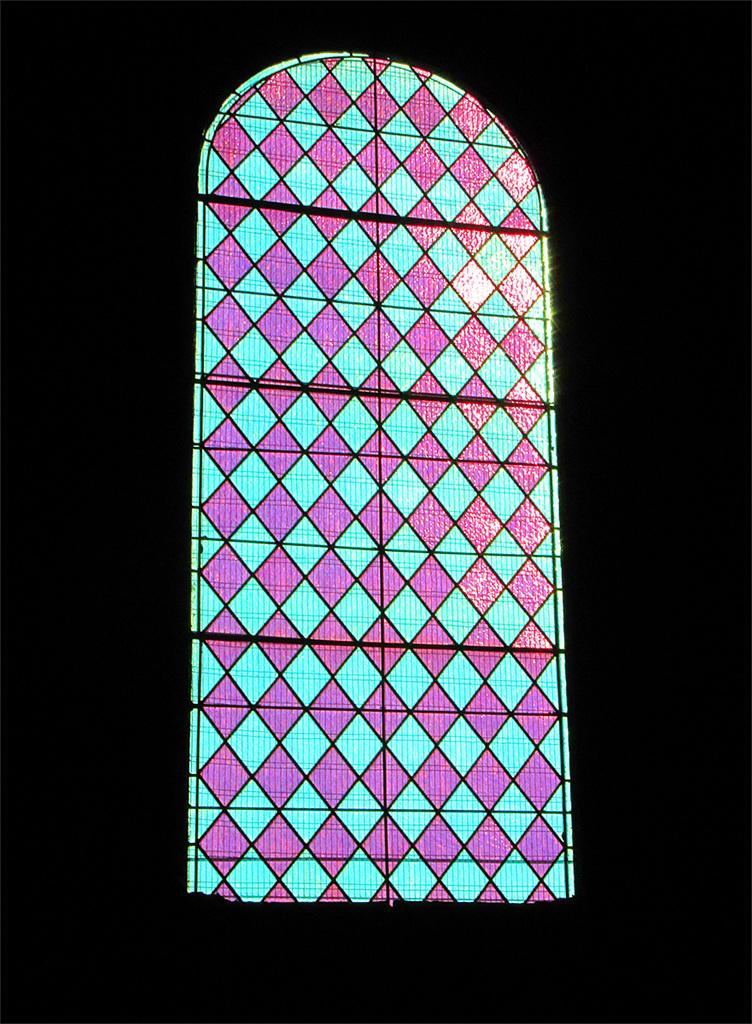What type of structure is present in the image? There is a glass window in the image. Can you see a goose standing near the stove in the image? There is no goose or stove present in the image; it only features a glass window. 